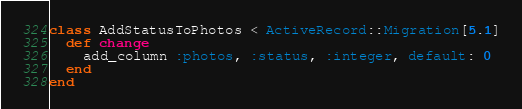Convert code to text. <code><loc_0><loc_0><loc_500><loc_500><_Ruby_>class AddStatusToPhotos < ActiveRecord::Migration[5.1]
  def change
    add_column :photos, :status, :integer, default: 0
  end
end
</code> 